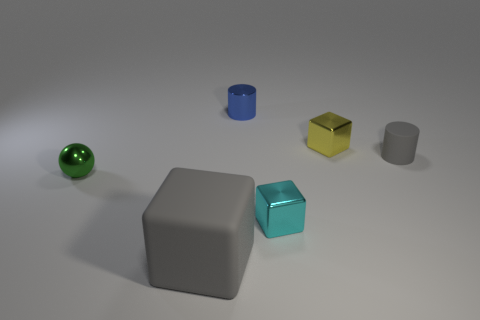There is a gray object that is the same size as the green thing; what is its material?
Provide a short and direct response. Rubber. The block that is both in front of the gray rubber cylinder and behind the large cube is made of what material?
Provide a short and direct response. Metal. There is a gray rubber object that is behind the big gray thing; is there a rubber cylinder that is in front of it?
Keep it short and to the point. No. There is a metallic object that is in front of the blue cylinder and behind the green object; what is its size?
Provide a succinct answer. Small. How many green objects are either shiny cylinders or small metallic balls?
Give a very brief answer. 1. There is a yellow metal thing that is the same size as the metal cylinder; what is its shape?
Offer a terse response. Cube. How many other things are there of the same color as the large block?
Make the answer very short. 1. How big is the gray matte cube that is left of the gray thing on the right side of the large gray thing?
Your response must be concise. Large. Are the object left of the gray block and the yellow cube made of the same material?
Make the answer very short. Yes. There is a gray thing behind the metal ball; what shape is it?
Give a very brief answer. Cylinder. 